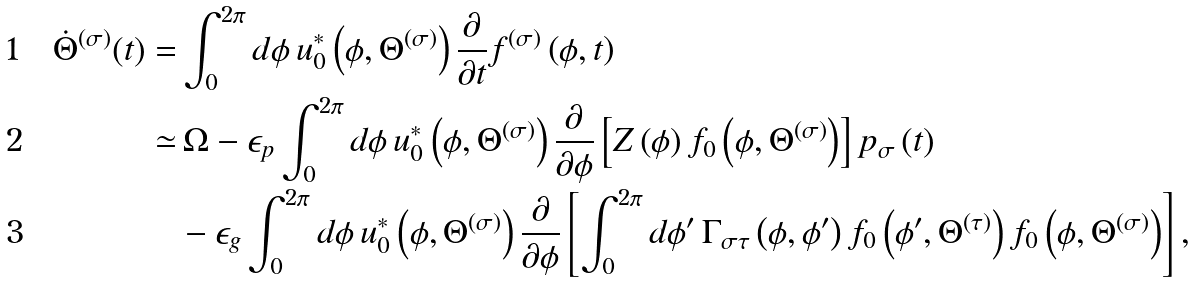<formula> <loc_0><loc_0><loc_500><loc_500>\dot { \Theta } ^ { ( \sigma ) } ( t ) = & \int _ { 0 } ^ { 2 \pi } d \phi \, u _ { 0 } ^ { \ast } \left ( \phi , \Theta ^ { ( \sigma ) } \right ) \frac { \partial } { \partial t } f ^ { ( \sigma ) } \left ( \phi , t \right ) \\ \simeq & \, \Omega - \epsilon _ { p } \int _ { 0 } ^ { 2 \pi } d \phi \, u _ { 0 } ^ { \ast } \left ( \phi , \Theta ^ { ( \sigma ) } \right ) \frac { \partial } { \partial \phi } \left [ Z \left ( \phi \right ) f _ { 0 } \left ( \phi , \Theta ^ { ( \sigma ) } \right ) \right ] p _ { \sigma } \left ( t \right ) \\ & - \epsilon _ { g } \int _ { 0 } ^ { 2 \pi } d \phi \, u _ { 0 } ^ { \ast } \left ( \phi , \Theta ^ { ( \sigma ) } \right ) \frac { \partial } { \partial \phi } \left [ \int _ { 0 } ^ { 2 \pi } d \phi ^ { \prime } \, \Gamma _ { \sigma \tau } \left ( \phi , \phi ^ { \prime } \right ) f _ { 0 } \left ( \phi ^ { \prime } , \Theta ^ { ( \tau ) } \right ) f _ { 0 } \left ( \phi , \Theta ^ { ( \sigma ) } \right ) \right ] ,</formula> 